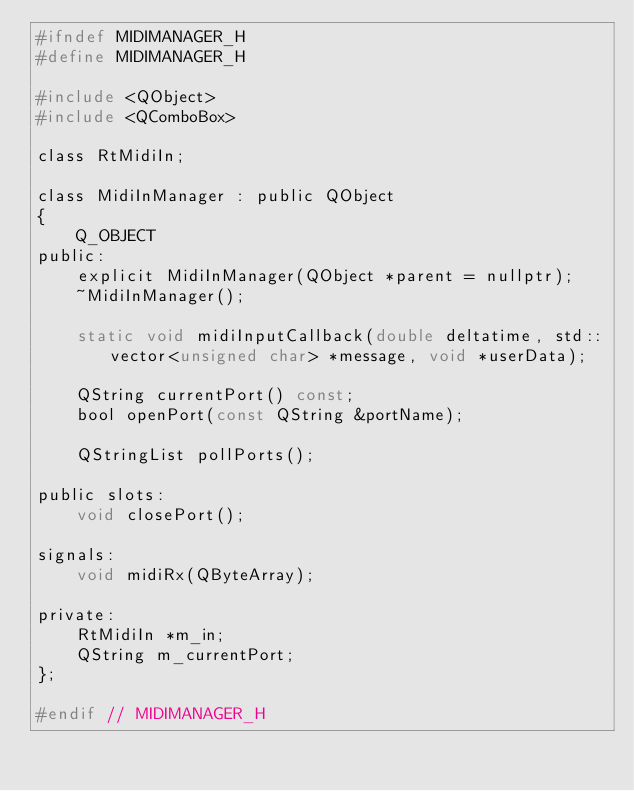Convert code to text. <code><loc_0><loc_0><loc_500><loc_500><_C_>#ifndef MIDIMANAGER_H
#define MIDIMANAGER_H

#include <QObject>
#include <QComboBox>

class RtMidiIn;

class MidiInManager : public QObject
{
    Q_OBJECT
public:
    explicit MidiInManager(QObject *parent = nullptr);
    ~MidiInManager();

    static void midiInputCallback(double deltatime, std::vector<unsigned char> *message, void *userData);

    QString currentPort() const;
    bool openPort(const QString &portName);

    QStringList pollPorts();

public slots:
    void closePort();

signals:
    void midiRx(QByteArray);

private:
    RtMidiIn *m_in;
    QString m_currentPort;
};

#endif // MIDIMANAGER_H
</code> 